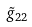Convert formula to latex. <formula><loc_0><loc_0><loc_500><loc_500>\tilde { g } _ { 2 2 }</formula> 